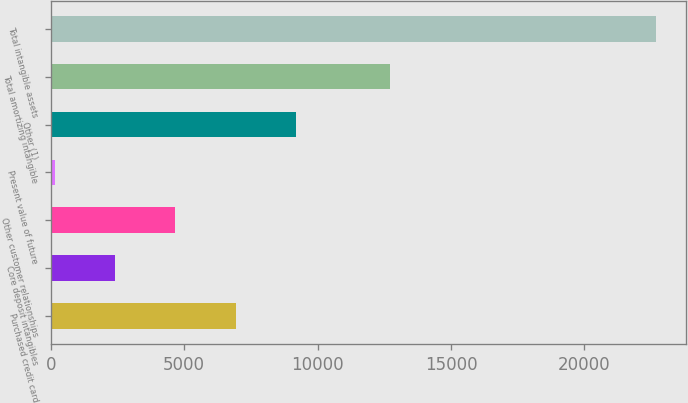<chart> <loc_0><loc_0><loc_500><loc_500><bar_chart><fcel>Purchased credit card<fcel>Core deposit intangibles<fcel>Other customer relationships<fcel>Present value of future<fcel>Other (1)<fcel>Total amortizing intangible<fcel>Total intangible assets<nl><fcel>6925.1<fcel>2421.7<fcel>4673.4<fcel>170<fcel>9176.8<fcel>12716<fcel>22687<nl></chart> 